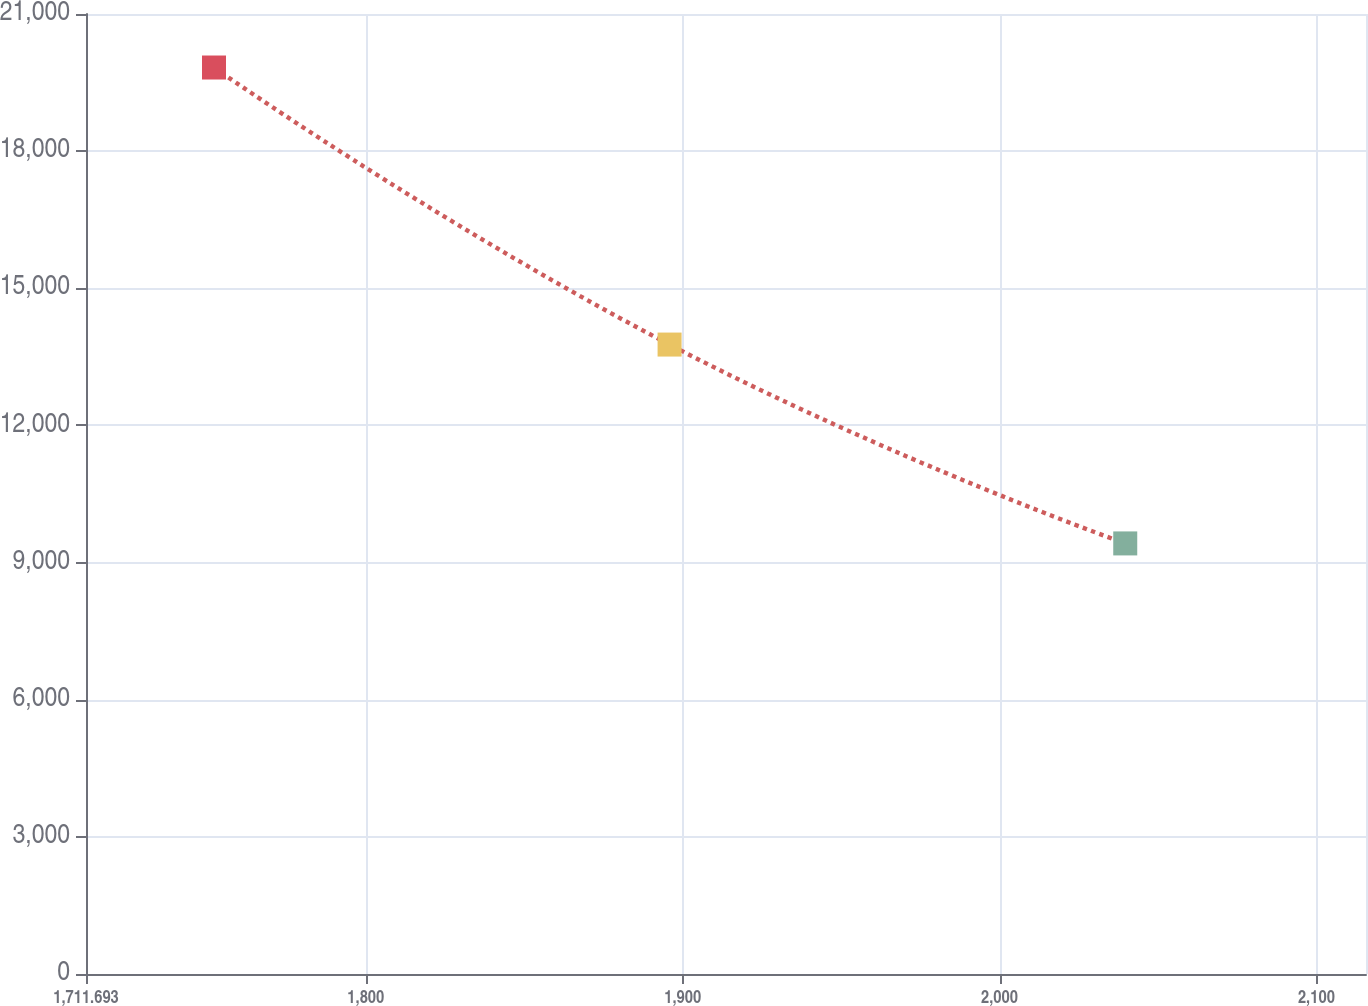Convert chart to OTSL. <chart><loc_0><loc_0><loc_500><loc_500><line_chart><ecel><fcel>Unnamed: 1<nl><fcel>1752.09<fcel>19829.5<nl><fcel>1895.87<fcel>13769<nl><fcel>2039.68<fcel>9418.94<nl><fcel>2156.06<fcel>7353.88<nl></chart> 